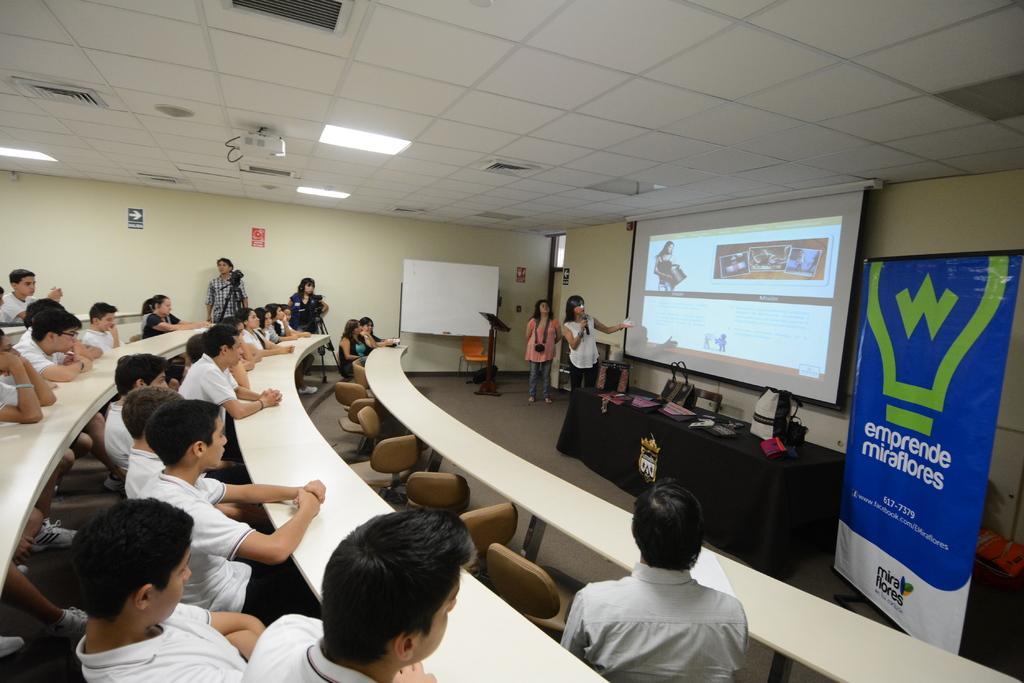Describe this image in one or two sentences. In the picture we can see a hall with benches and chairs on the chairs we can see some people are sitting and they are in a white T-shirts and two people are standing and near them we can see cameras on the tripods and in front of them we can see a desk and some bags on it and beside it we can see a woman standing and talking in a microphone looking to the screen and behind her we can see one woman standing and in the background we can see a wall and a white color board and to the ceiling we can see some lights and a projector. 